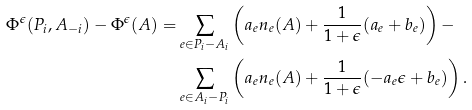Convert formula to latex. <formula><loc_0><loc_0><loc_500><loc_500>\Phi ^ { \epsilon } ( P _ { i } , A _ { - i } ) - \Phi ^ { \epsilon } ( A ) = & \sum _ { e \in P _ { i } - A _ { i } } \left ( a _ { e } n _ { e } ( A ) + \frac { 1 } { 1 + \epsilon } ( a _ { e } + b _ { e } ) \right ) - \\ & \sum _ { e \in A _ { i } - P _ { i } } \left ( a _ { e } n _ { e } ( A ) + \frac { 1 } { 1 + \epsilon } ( - a _ { e } \epsilon + b _ { e } ) \right ) .</formula> 